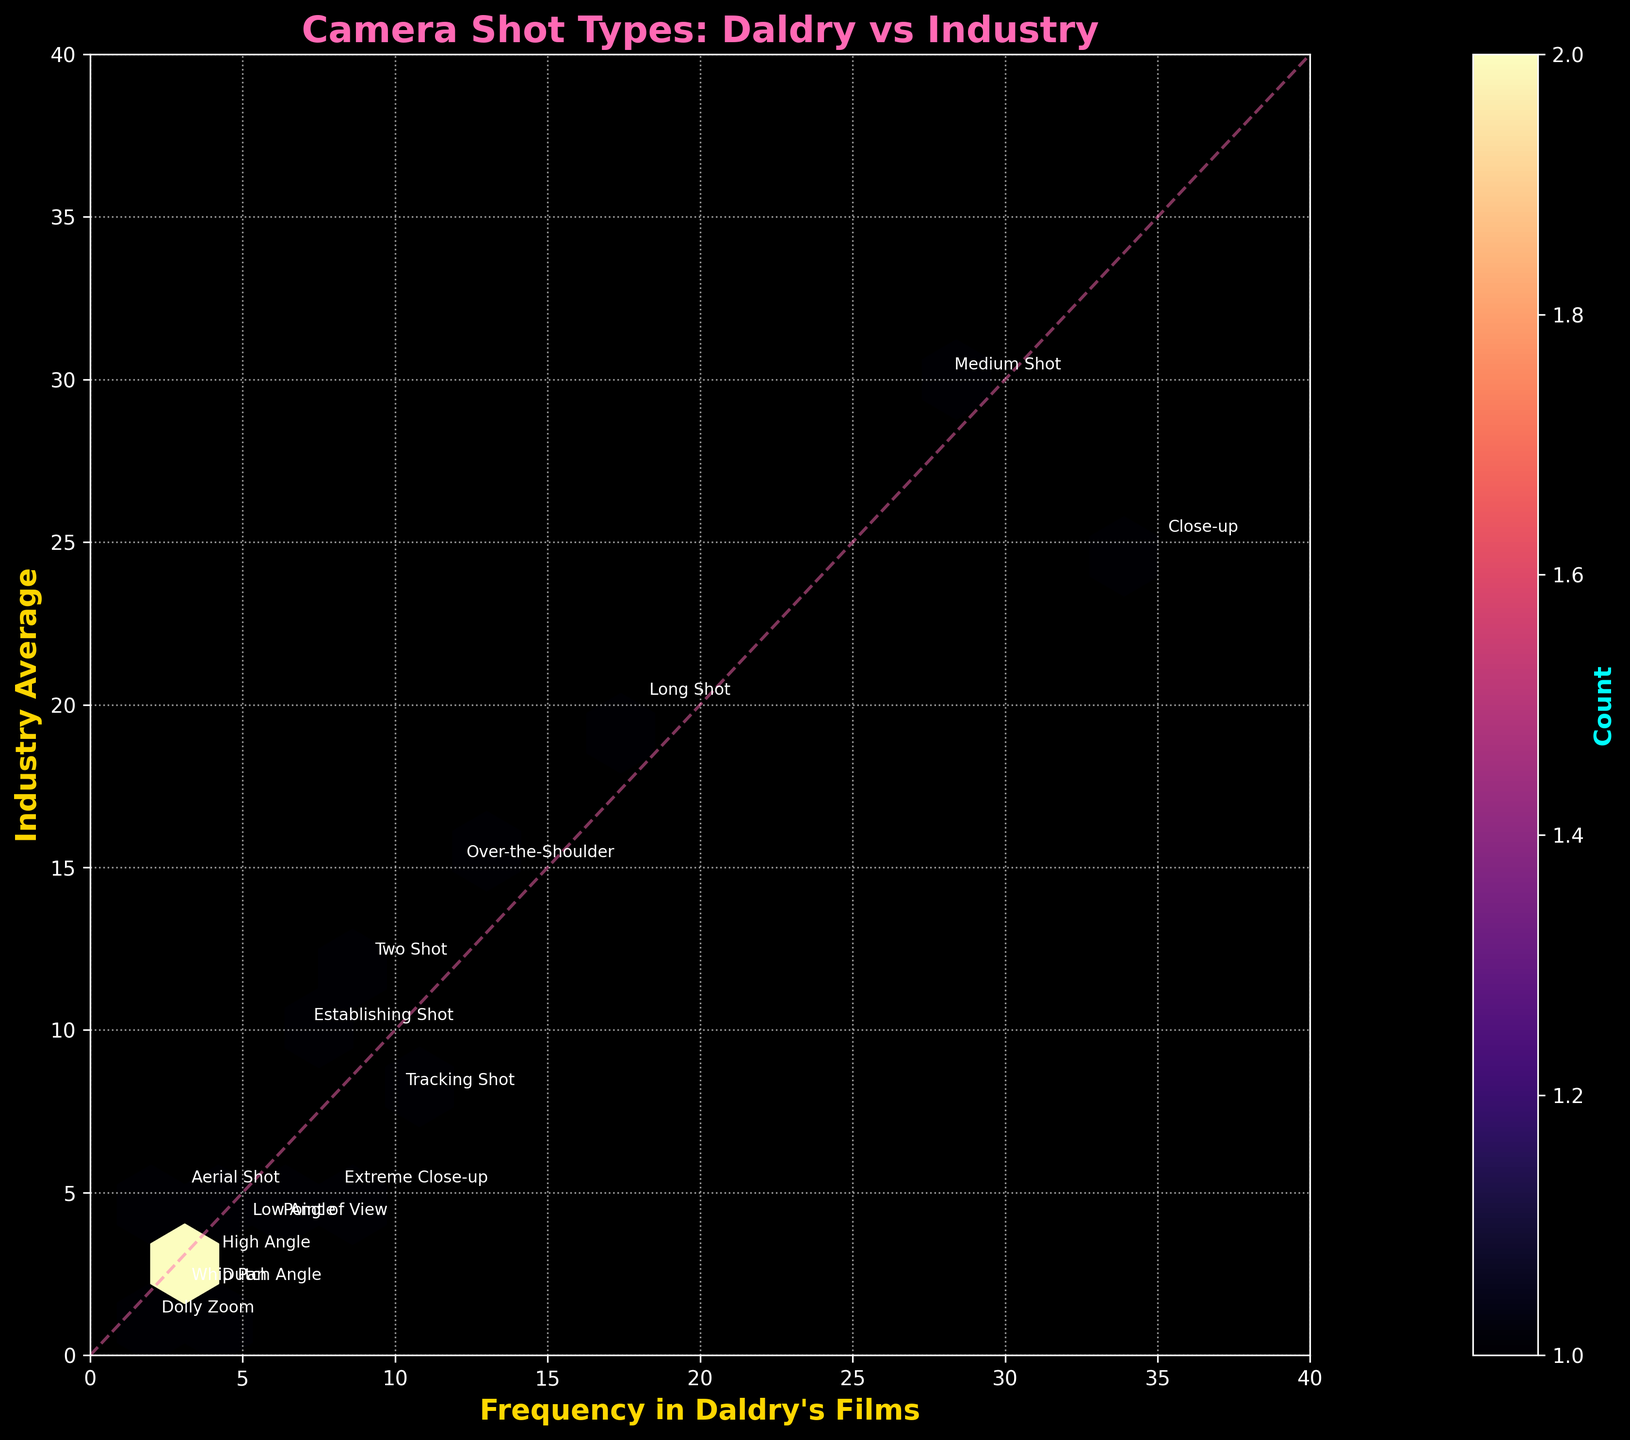what is the title of the plot? The title is usually located at the top of the plot and is designed to provide a brief summary of the plot's main topic or purpose. In this plot, the title says "Camera Shot Types: Daldry vs Industry", which indicates a comparison of shot types used by Stephen Daldry to industry averages.
Answer: Camera Shot Types: Daldry vs Industry Which axis shows the frequency of camera shot types used in Daldry’s films? The axes are labeled to indicate what data is represented. The x-axis is labeled "Frequency in Daldry's Films". This means it shows the frequencies of different camera shot types as used by Stephen Daldry in his films.
Answer: The x-axis What color is used for the hexbin plot to represent the count of camera shot types? The color representing the count is controlled by the color map used in the plot. In the given code, the colormap `magma` is used, which ranges from dark to light hues typically in shades of purple and orange. You can see this color gradient in the color bar and the hexagons in the plot.
Answer: Shades of purple and orange What is the frequency of 'Extreme Close-up' shots in Daldry's films? To find this, you look for the label "Extreme Close-up" and the corresponding point it is annotated on. Based on the provided data, 'Extreme Close-up' is annotated at the point where the x coordinate (frequency in Daldry's films) is 8.
Answer: 8 How does the frequency of 'Close-up' shots in Daldry’s films compare to industry average? By looking at the point where "Close-up" is annotated, you see the x coordinate is 35 (Daldry's frequency) and the y coordinate is 25 (industry average). Thus, Daldry uses 'Close-up' shots more frequently than the industry average.
Answer: Daldry uses 'Close-up' shots more frequently Between which camera shot types is the largest discrepancy in usage between Daldry's films and the industry average? By observing the data points and annotations, you can determine the largest difference in x and y coordinates. 'Close-up' shots show a large difference, with Daldry using them 35 times (x-axis) and the industry average being 25 (y-axis), leading to the largest observed discrepancy.
Answer: Close-up What is the average frequency of 'Dolly Zoom' shots considering both Daldry's films and industry average? The frequency in Daldry's films for 'Dolly Zoom' is 2 and the industry average is 1. To find the average: (2 + 1) / 2 = 1.5.
Answer: 1.5 Is the frequency of 'Tracking Shot' in Daldry's films higher or lower than the industry average? The point for 'Tracking Shot' shows the corresponding frequency in Daldry's films as 10 (x coordinate) and the industry average as 8 (y coordinate). Since 10 is greater than 8, Daldry uses 'Tracking Shot' more frequently.
Answer: Higher What does the dashed diagonal line in the plot signify? The dashed line is a reference line where the x value equals the y value, representing equal frequency in both Daldry’s films and the industry. Points above this line indicate higher usage in Daldry’s films, while points below suggest higher industry average usage.
Answer: Equal usage How many camera shot types do Daldry's films use more frequently than the industry average? Points above the dashed diagonal line indicate more frequent usage in Daldry's films. By counting the points above the line, we see that Daldry uses 'Close-up', 'Extreme Close-up', 'Tracking Shot', 'Point of View', 'Dutch Angle', and 'Low Angle' more frequently than the industry. This sums to 6 types.
Answer: 6 